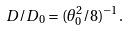Convert formula to latex. <formula><loc_0><loc_0><loc_500><loc_500>D / D _ { 0 } = ( \theta _ { 0 } ^ { 2 } / 8 ) ^ { - 1 } .</formula> 